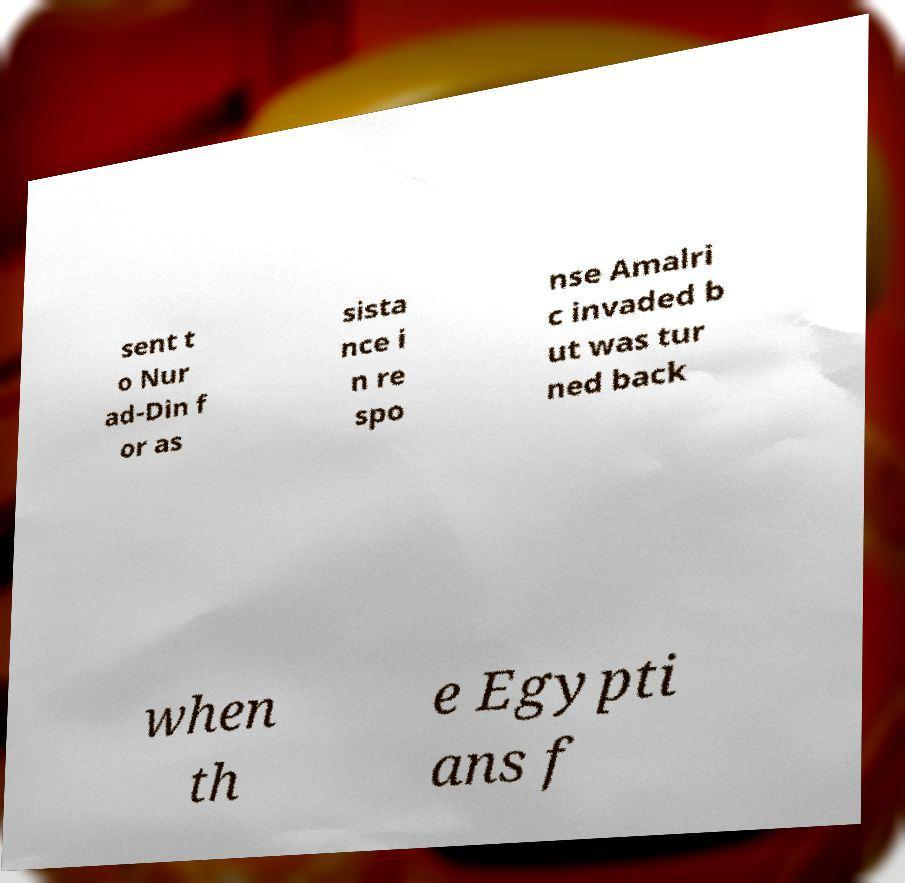Could you assist in decoding the text presented in this image and type it out clearly? sent t o Nur ad-Din f or as sista nce i n re spo nse Amalri c invaded b ut was tur ned back when th e Egypti ans f 